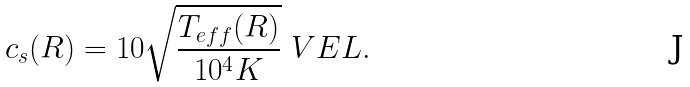Convert formula to latex. <formula><loc_0><loc_0><loc_500><loc_500>c _ { s } ( R ) = 1 0 \sqrt { \frac { T _ { e f f } ( R ) } { 1 0 ^ { 4 } K } } \ V E L .</formula> 